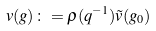Convert formula to latex. <formula><loc_0><loc_0><loc_500><loc_500>v ( g ) \colon = \rho ( q ^ { - 1 } ) \tilde { v } ( g _ { 0 } )</formula> 